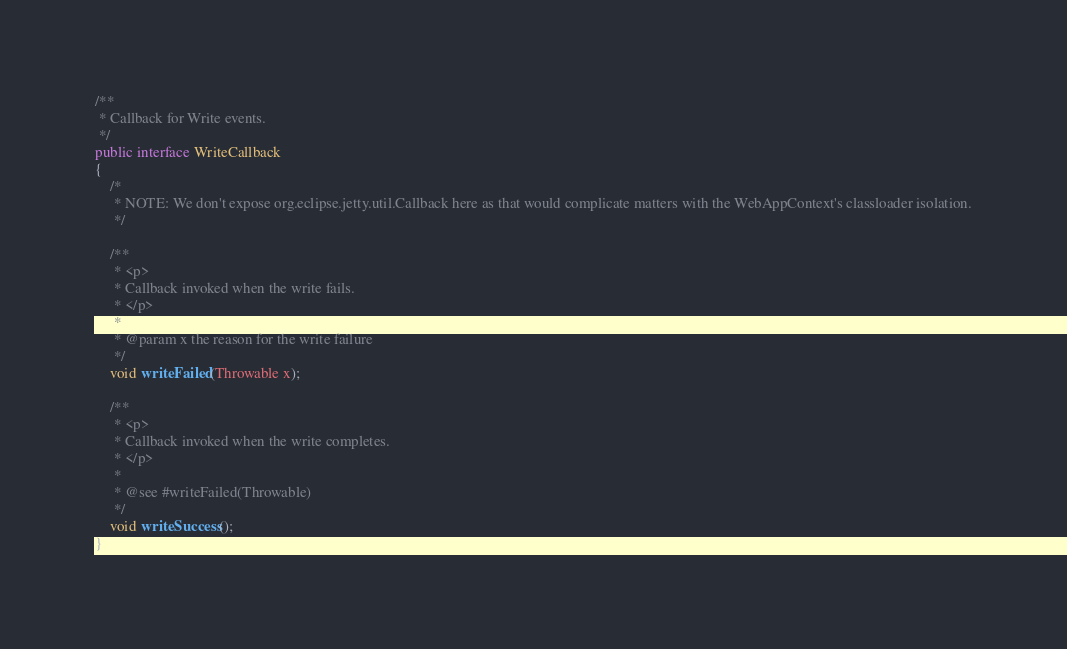Convert code to text. <code><loc_0><loc_0><loc_500><loc_500><_Java_>
/**
 * Callback for Write events.
 */
public interface WriteCallback
{
    /*
     * NOTE: We don't expose org.eclipse.jetty.util.Callback here as that would complicate matters with the WebAppContext's classloader isolation.
     */

    /**
     * <p>
     * Callback invoked when the write fails.
     * </p>
     *
     * @param x the reason for the write failure
     */
    void writeFailed(Throwable x);

    /**
     * <p>
     * Callback invoked when the write completes.
     * </p>
     *
     * @see #writeFailed(Throwable)
     */
    void writeSuccess();
}
</code> 